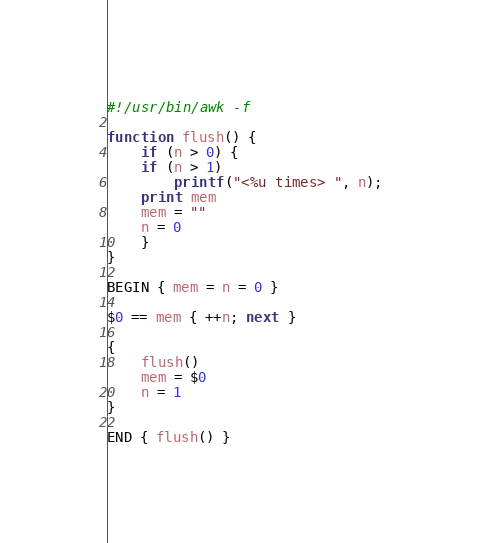Convert code to text. <code><loc_0><loc_0><loc_500><loc_500><_Awk_>#!/usr/bin/awk -f

function flush() {
    if (n > 0) {
	if (n > 1)
	    printf("<%u times> ", n);
	print mem
	mem = ""
	n = 0
    }
}

BEGIN { mem = n = 0 }

$0 == mem { ++n; next }

{
    flush()
    mem = $0
    n = 1
}

END { flush() }
</code> 